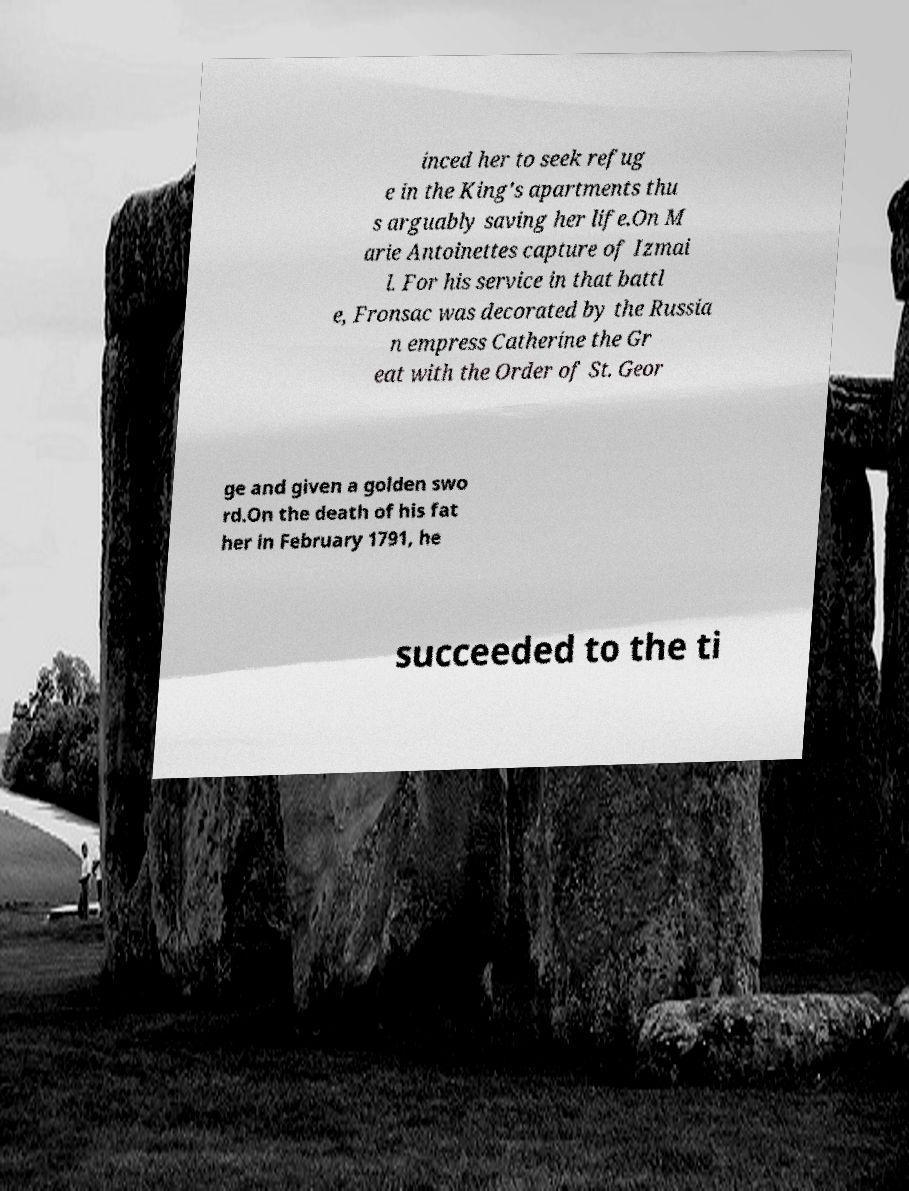Could you assist in decoding the text presented in this image and type it out clearly? inced her to seek refug e in the King's apartments thu s arguably saving her life.On M arie Antoinettes capture of Izmai l. For his service in that battl e, Fronsac was decorated by the Russia n empress Catherine the Gr eat with the Order of St. Geor ge and given a golden swo rd.On the death of his fat her in February 1791, he succeeded to the ti 